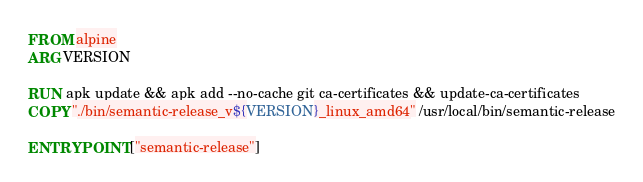<code> <loc_0><loc_0><loc_500><loc_500><_Dockerfile_>FROM alpine
ARG VERSION

RUN apk update && apk add --no-cache git ca-certificates && update-ca-certificates
COPY "./bin/semantic-release_v${VERSION}_linux_amd64" /usr/local/bin/semantic-release

ENTRYPOINT ["semantic-release"]
</code> 